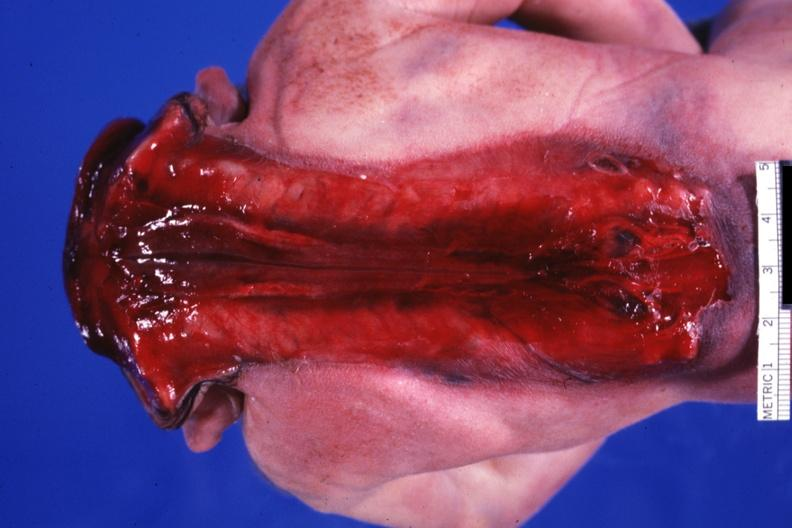what is present with open spine?
Answer the question using a single word or phrase. Anencephaly 